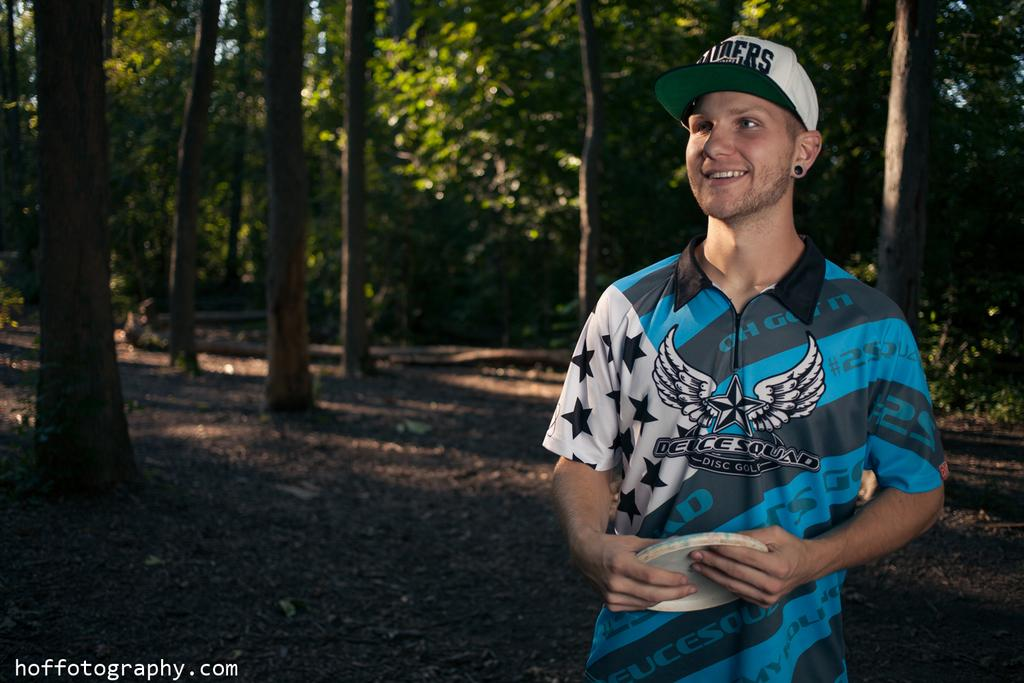What is the main subject in the foreground of the image? There is a person wearing a cap in the foreground of the image. What can be seen in the background of the image? There are trees in the background of the image. What type of surface is visible at the bottom of the image? Soil is visible at the bottom of the image. Is there any text present in the image? Yes, there is text in the image. How many cars are parked in the scene depicted in the image? There are no cars present in the image; it features a person wearing a cap, trees in the background, soil at the bottom, and text. 